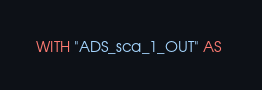Convert code to text. <code><loc_0><loc_0><loc_500><loc_500><_SQL_>WITH "ADS_sca_1_OUT" AS </code> 